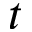<formula> <loc_0><loc_0><loc_500><loc_500>t</formula> 